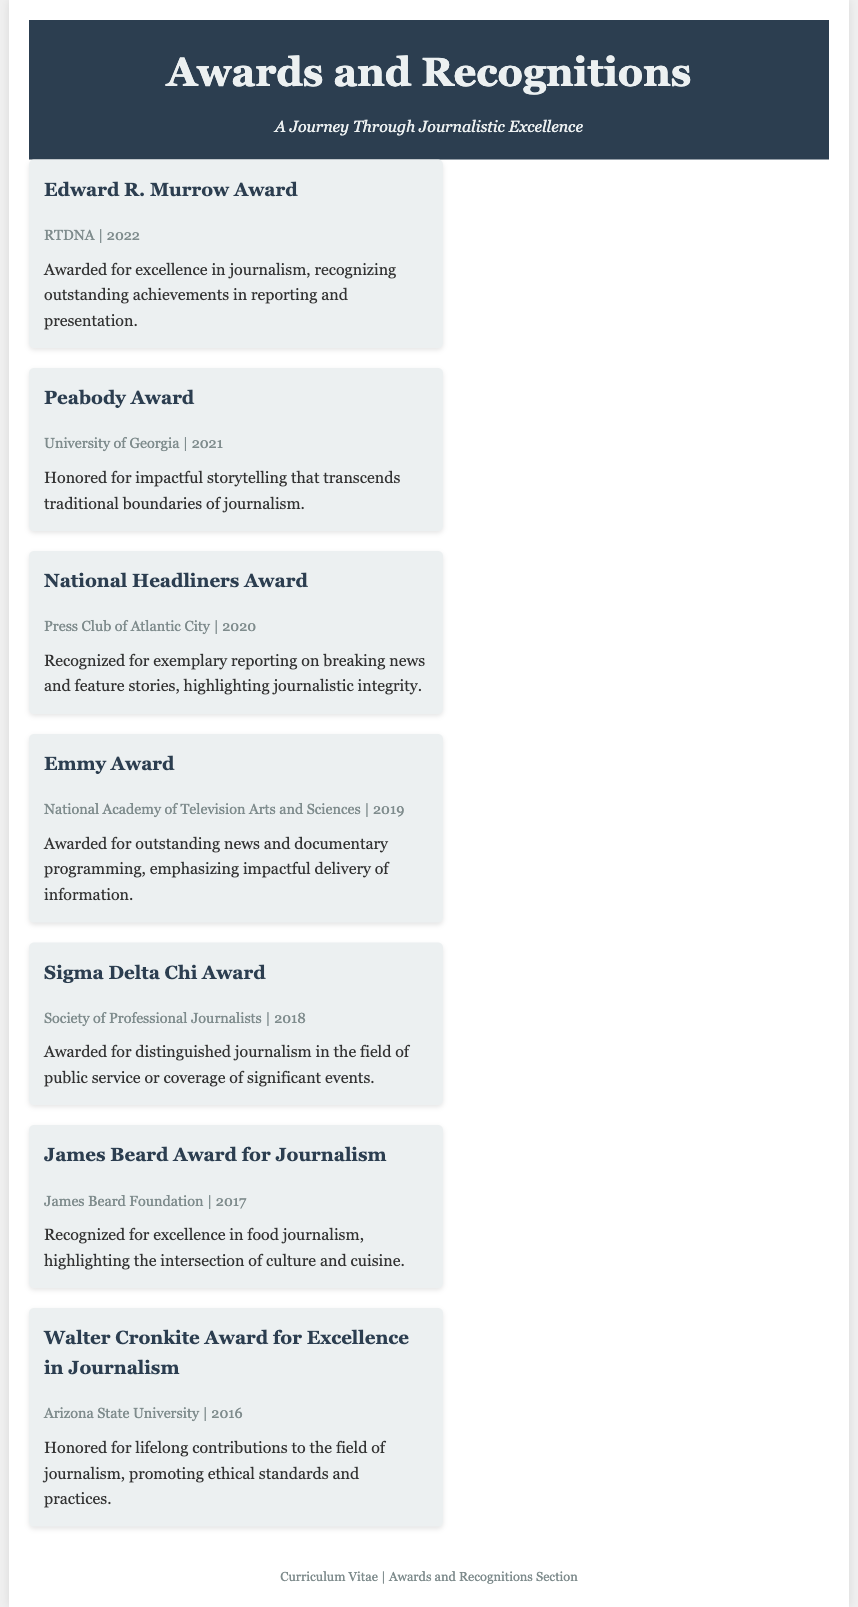what award was received in 2022? The award received in 2022 is the Edward R. Murrow Award, which is a notable recognition in journalism.
Answer: Edward R. Murrow Award who awarded the Peabody Award? The Peabody Award was awarded by the University of Georgia, indicating an academic and prestigious recognition in journalism.
Answer: University of Georgia what is the main focus of the James Beard Award for Journalism? The main focus of the James Beard Award for Journalism is on food journalism, particularly its cultural significance and narrative.
Answer: Food journalism how many awards are listed in the document? The document lists a total of seven awards, showcasing various recognitions in the field of journalism.
Answer: Seven which award emphasizes 'impactful delivery of information'? The Emmy Award emphasizes impactful delivery of information, highlighting its importance in news programming and documentaries.
Answer: Emmy Award what type of journalism is recognized by the Sigma Delta Chi Award? The Sigma Delta Chi Award recognizes distinguished journalism in public service or coverage of significant events, focusing on journalistic integrity.
Answer: Public service journalism in what year was the Walter Cronkite Award received? The Walter Cronkite Award for Excellence in Journalism was received in 2016, marking a significant achievement in the journalist's career.
Answer: 2016 which organization presents the National Headliners Award? The National Headliners Award is presented by the Press Club of Atlantic City, highlighting notable achievements in journalism.
Answer: Press Club of Atlantic City 